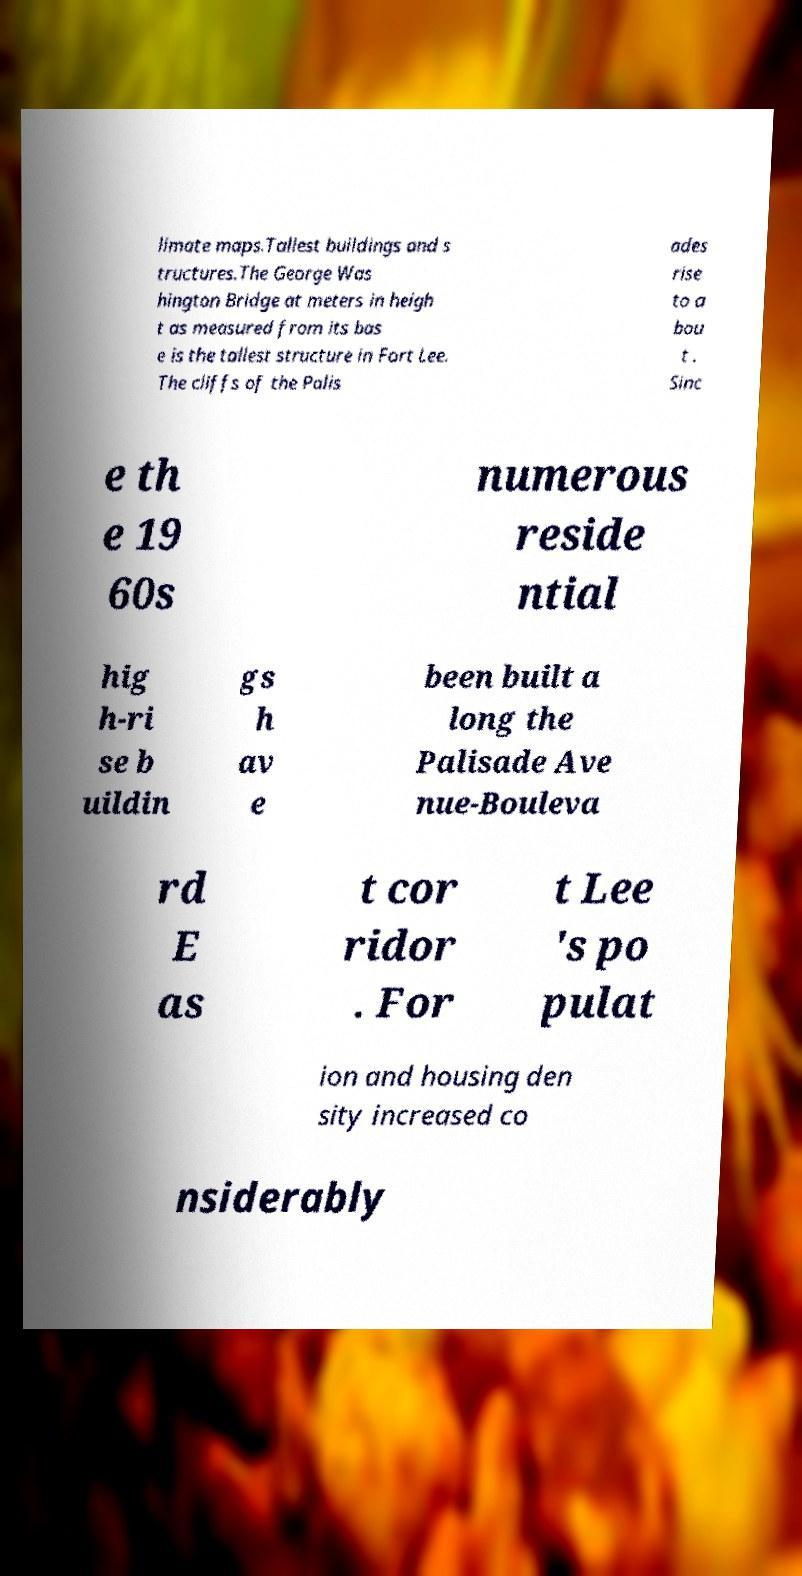Can you accurately transcribe the text from the provided image for me? limate maps.Tallest buildings and s tructures.The George Was hington Bridge at meters in heigh t as measured from its bas e is the tallest structure in Fort Lee. The cliffs of the Palis ades rise to a bou t . Sinc e th e 19 60s numerous reside ntial hig h-ri se b uildin gs h av e been built a long the Palisade Ave nue-Bouleva rd E as t cor ridor . For t Lee 's po pulat ion and housing den sity increased co nsiderably 